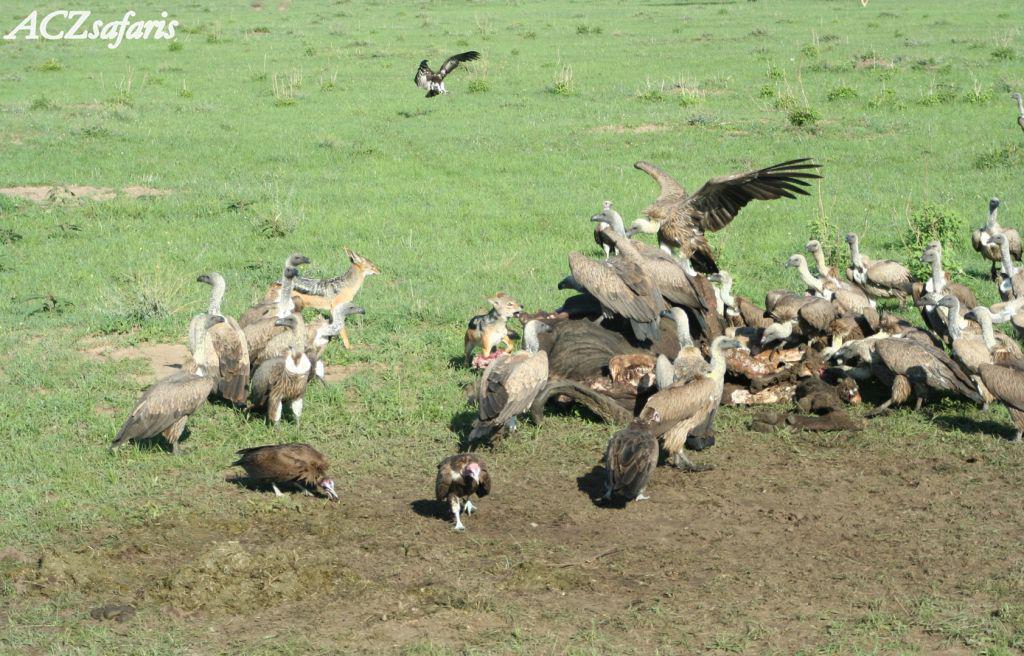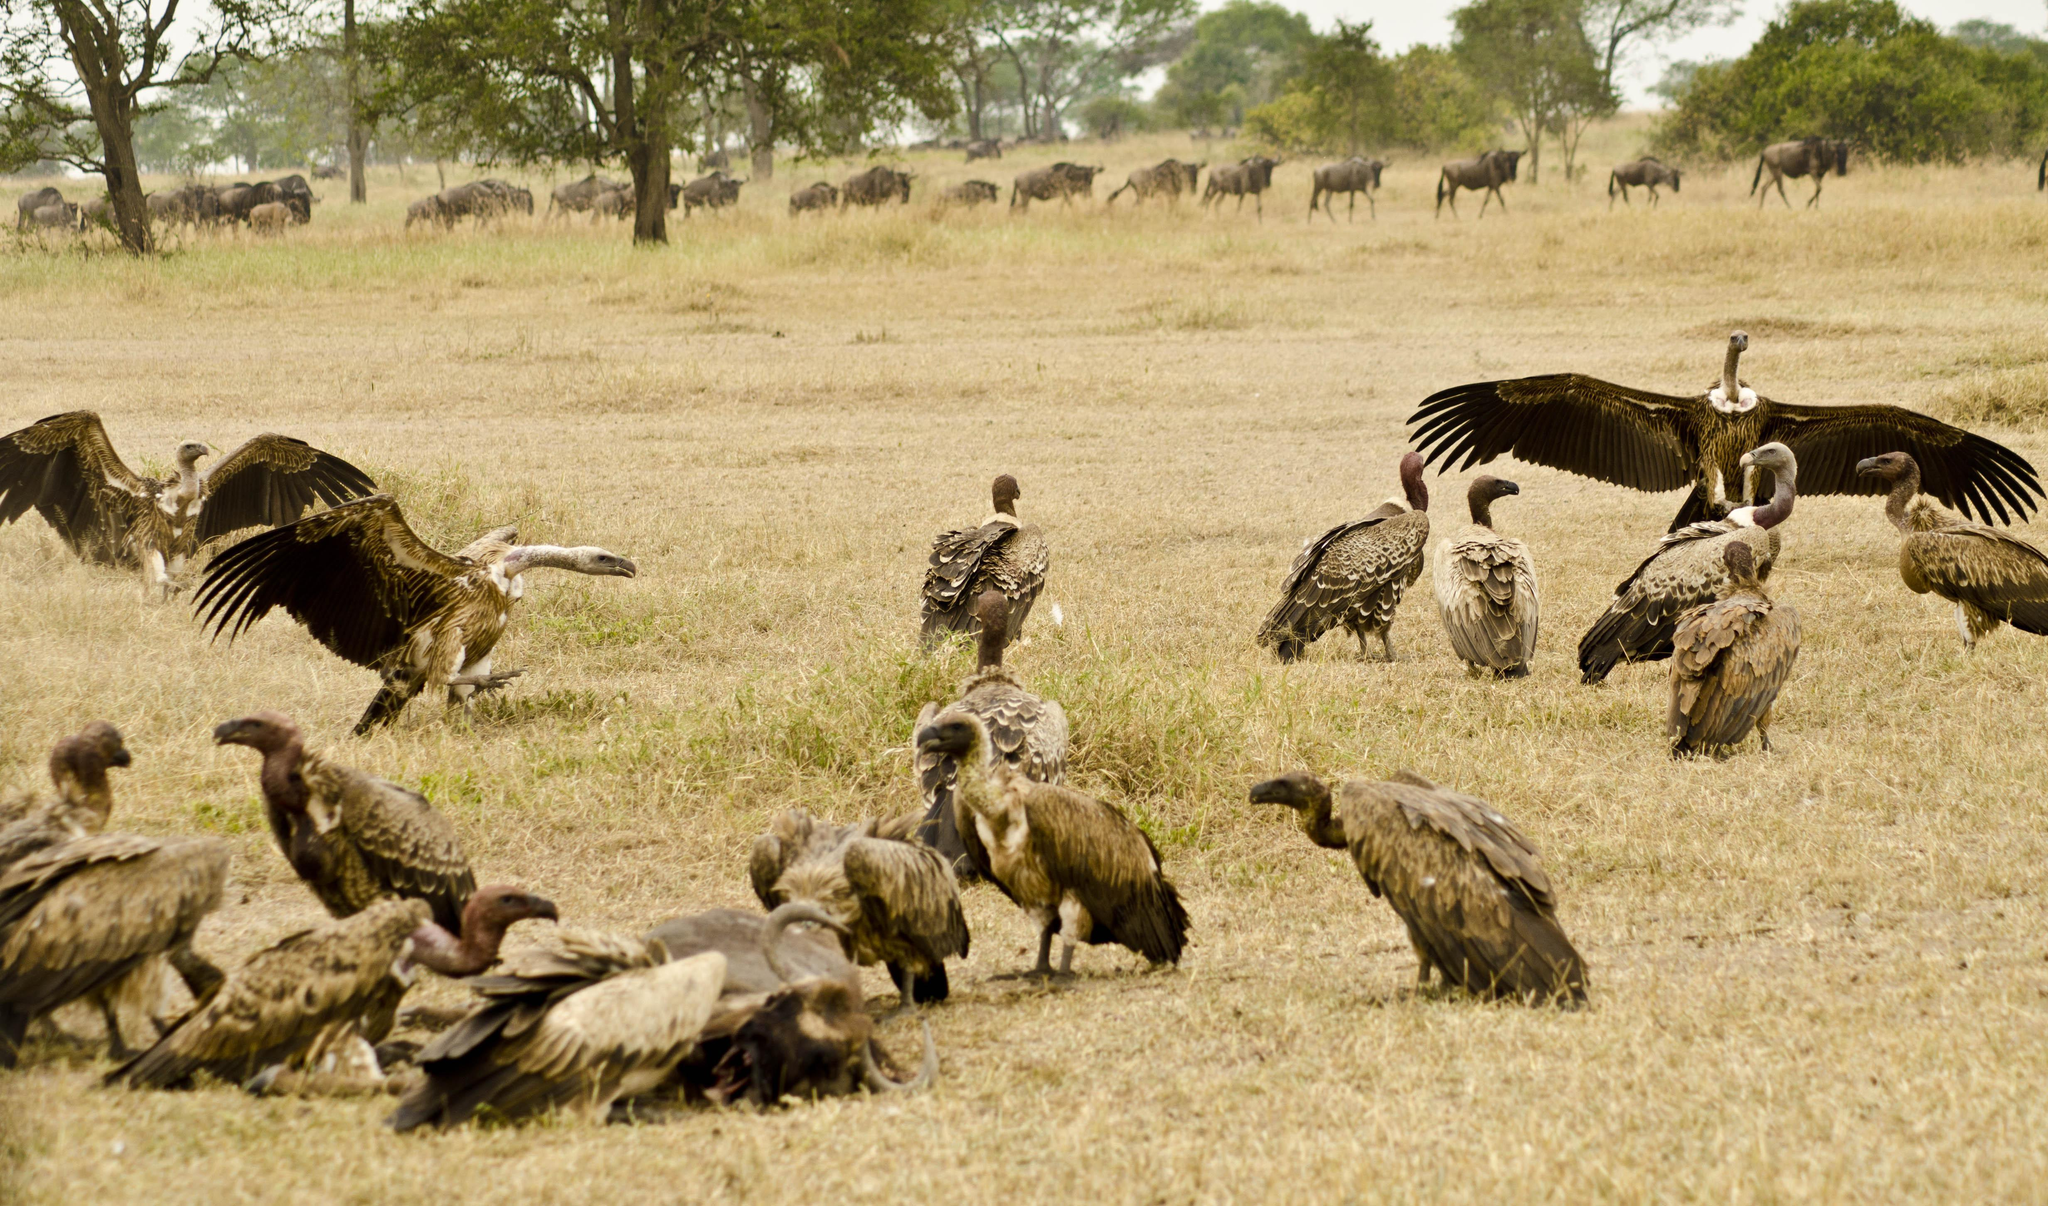The first image is the image on the left, the second image is the image on the right. Considering the images on both sides, is "In one image, you can see a line of hooved-type animals in the background behind the vultures." valid? Answer yes or no. Yes. 